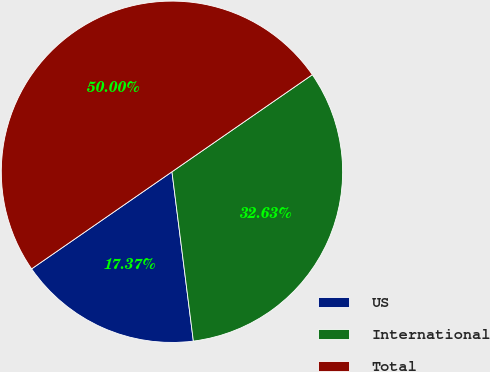<chart> <loc_0><loc_0><loc_500><loc_500><pie_chart><fcel>US<fcel>International<fcel>Total<nl><fcel>17.37%<fcel>32.63%<fcel>50.0%<nl></chart> 